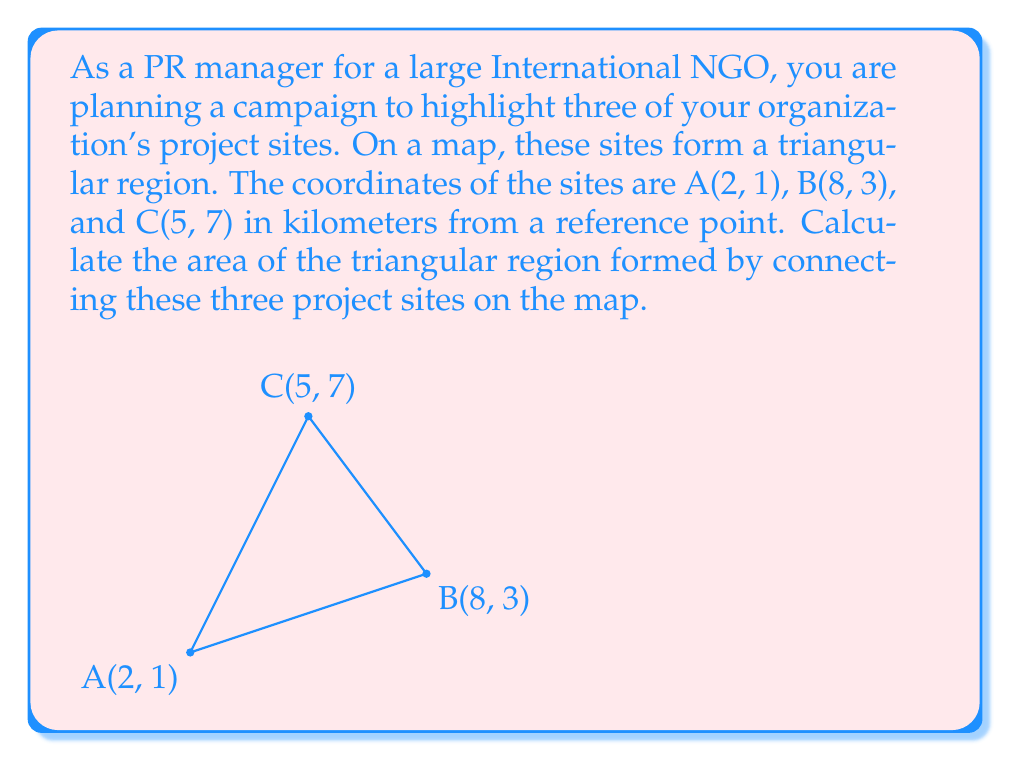Give your solution to this math problem. To solve this problem, we'll use the formula for the area of a triangle given the coordinates of its vertices. The formula is:

$$\text{Area} = \frac{1}{2}|x_1(y_2 - y_3) + x_2(y_3 - y_1) + x_3(y_1 - y_2)|$$

Where $(x_1, y_1)$, $(x_2, y_2)$, and $(x_3, y_3)$ are the coordinates of the three vertices.

Given:
- A(2, 1)
- B(8, 3)
- C(5, 7)

Let's substitute these values into the formula:

$$\begin{aligned}
\text{Area} &= \frac{1}{2}|2(3 - 7) + 8(7 - 1) + 5(1 - 3)| \\
&= \frac{1}{2}|2(-4) + 8(6) + 5(-2)| \\
&= \frac{1}{2}|-8 + 48 - 10| \\
&= \frac{1}{2}|30| \\
&= \frac{1}{2} \cdot 30 \\
&= 15
\end{aligned}$$

The units are in square kilometers since the original coordinates were given in kilometers.
Answer: The area of the triangular region formed by the three project sites is 15 square kilometers. 